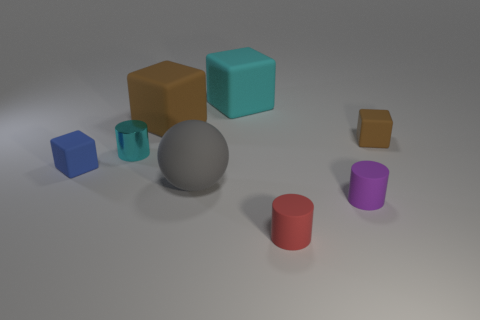The small rubber block that is to the left of the brown matte cube on the right side of the small purple cylinder is what color?
Your response must be concise. Blue. What is the material of the purple thing that is the same shape as the tiny cyan object?
Your answer should be compact. Rubber. The small matte block that is in front of the small cylinder that is behind the small blue rubber cube that is left of the red matte object is what color?
Keep it short and to the point. Blue. How many things are either big purple metal things or brown things?
Make the answer very short. 2. What number of other rubber objects are the same shape as the small red thing?
Keep it short and to the point. 1. Do the cyan cube and the cyan thing in front of the cyan block have the same material?
Keep it short and to the point. No. What size is the cyan object that is made of the same material as the tiny purple cylinder?
Your answer should be very brief. Large. There is a cyan thing that is to the right of the large brown cube; what size is it?
Offer a very short reply. Large. How many brown blocks have the same size as the purple object?
Offer a terse response. 1. What size is the matte block that is the same color as the small shiny cylinder?
Your response must be concise. Large. 